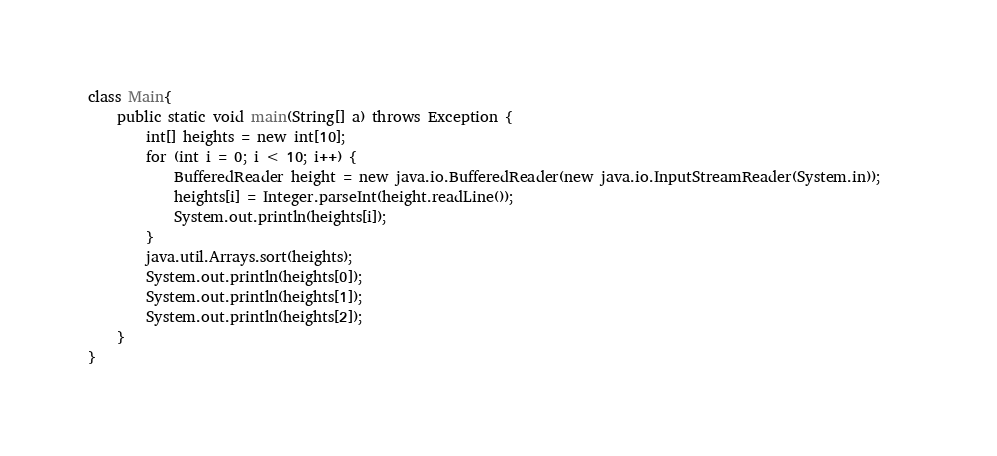<code> <loc_0><loc_0><loc_500><loc_500><_Java_>
class Main{
	public static void main(String[] a) throws Exception {
		int[] heights = new int[10];
		for (int i = 0; i < 10; i++) {
			BufferedReader height = new java.io.BufferedReader(new java.io.InputStreamReader(System.in));	
			heights[i] = Integer.parseInt(height.readLine());
			System.out.println(heights[i]);
		}
		java.util.Arrays.sort(heights);
		System.out.println(heights[0]);
		System.out.println(heights[1]);
		System.out.println(heights[2]);
	}
}</code> 